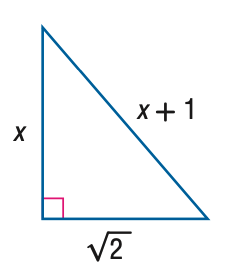Answer the mathemtical geometry problem and directly provide the correct option letter.
Question: Find x.
Choices: A: 0.5 B: 1 C: 2 D: 3 A 